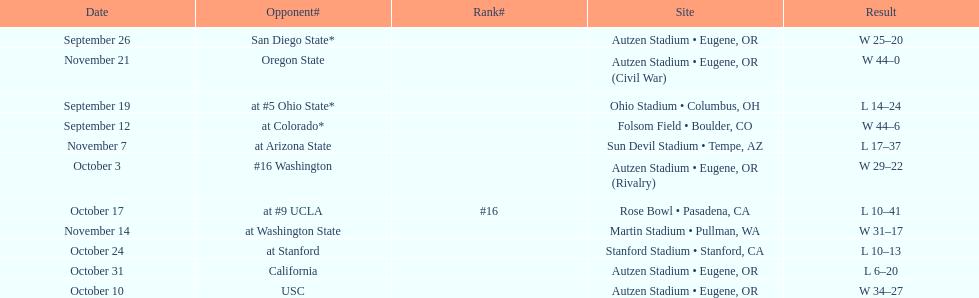How many games did the team win while not at home? 2. 